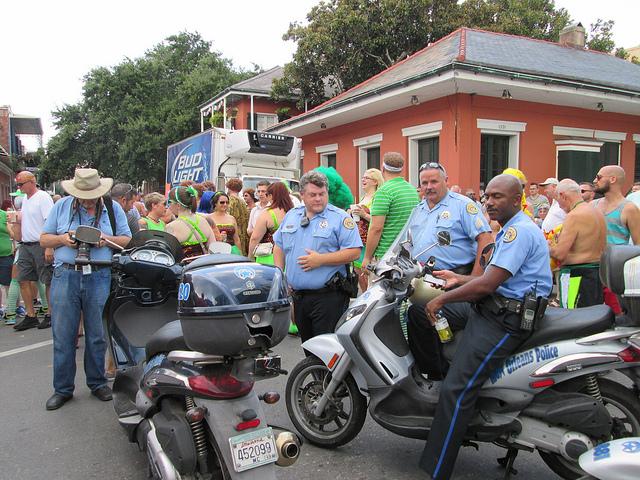Are some of the men bald?
Give a very brief answer. Yes. Who is providing the beer?
Be succinct. Bud light. How many policeman are pictured?
Quick response, please. 3. 